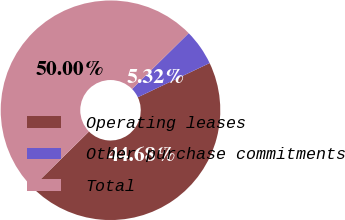Convert chart. <chart><loc_0><loc_0><loc_500><loc_500><pie_chart><fcel>Operating leases<fcel>Other purchase commitments<fcel>Total<nl><fcel>44.68%<fcel>5.32%<fcel>50.0%<nl></chart> 